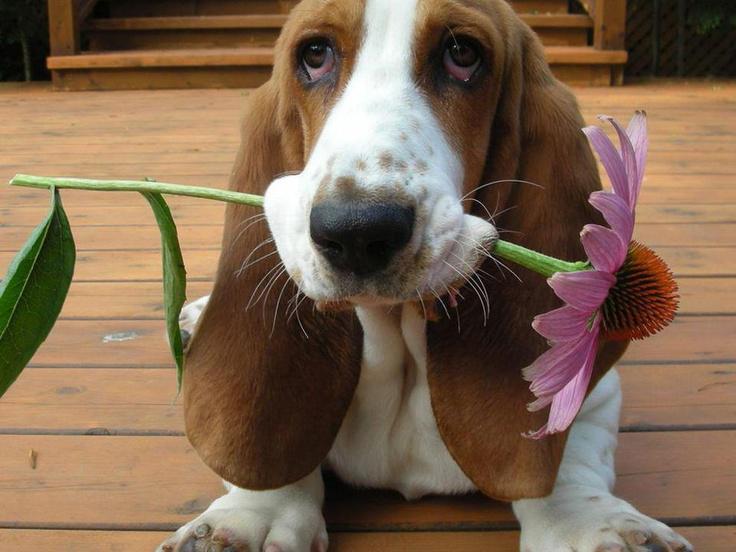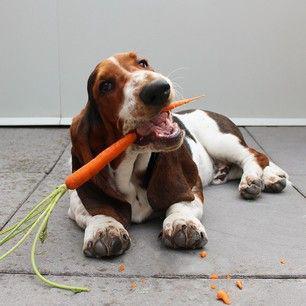The first image is the image on the left, the second image is the image on the right. Examine the images to the left and right. Is the description "In one of the images there is a dog eating a carrot." accurate? Answer yes or no. Yes. The first image is the image on the left, the second image is the image on the right. Examine the images to the left and right. Is the description "One of the images shows at least one Basset Hound with something in their mouth." accurate? Answer yes or no. Yes. 